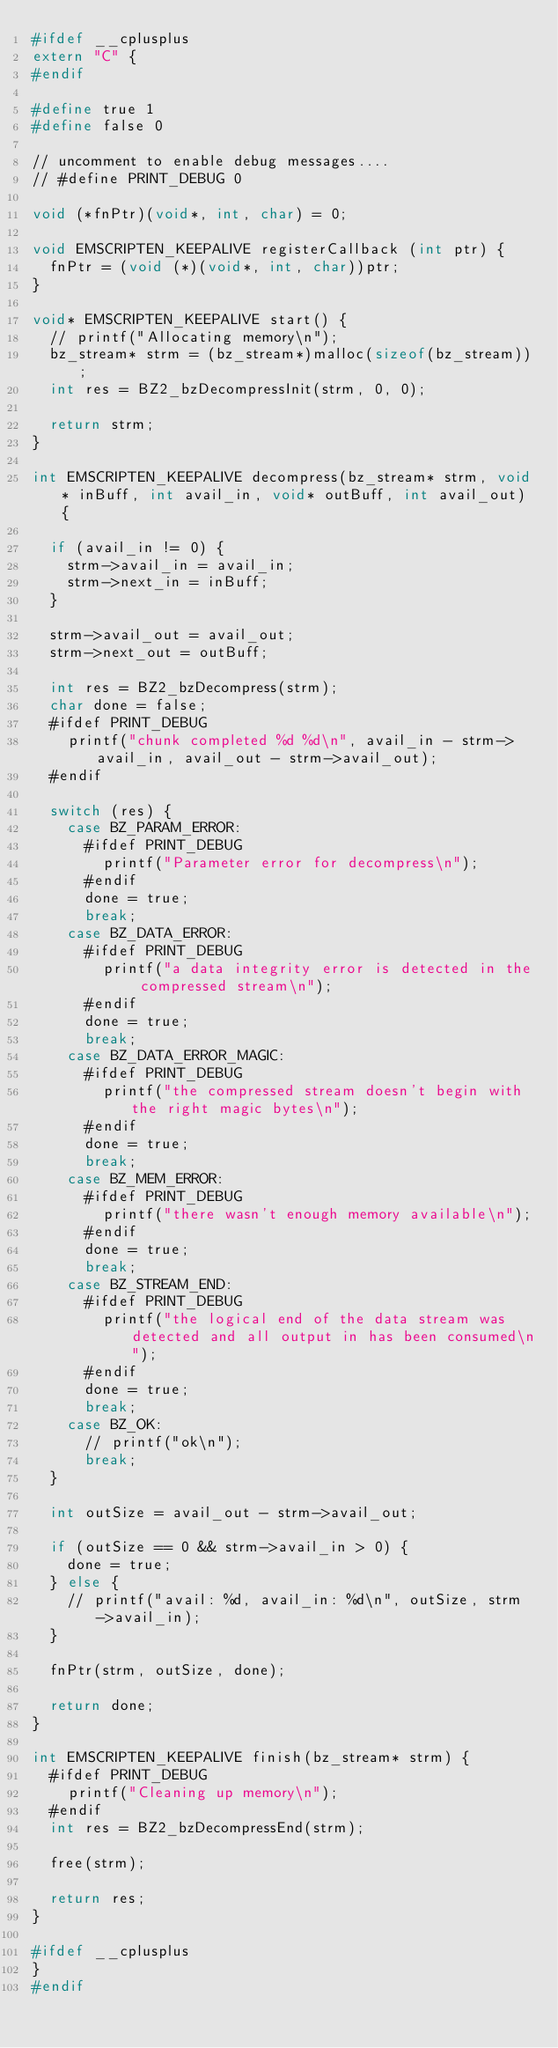<code> <loc_0><loc_0><loc_500><loc_500><_C_>#ifdef __cplusplus
extern "C" {
#endif

#define true 1
#define false 0

// uncomment to enable debug messages....
// #define PRINT_DEBUG 0

void (*fnPtr)(void*, int, char) = 0;

void EMSCRIPTEN_KEEPALIVE registerCallback (int ptr) {
  fnPtr = (void (*)(void*, int, char))ptr;
}

void* EMSCRIPTEN_KEEPALIVE start() {
  // printf("Allocating memory\n");
  bz_stream* strm = (bz_stream*)malloc(sizeof(bz_stream));
  int res = BZ2_bzDecompressInit(strm, 0, 0);

  return strm;
}

int EMSCRIPTEN_KEEPALIVE decompress(bz_stream* strm, void* inBuff, int avail_in, void* outBuff, int avail_out) {
  
  if (avail_in != 0) {
    strm->avail_in = avail_in;
    strm->next_in = inBuff;
  }

  strm->avail_out = avail_out;
  strm->next_out = outBuff;

  int res = BZ2_bzDecompress(strm);
  char done = false;
  #ifdef PRINT_DEBUG
    printf("chunk completed %d %d\n", avail_in - strm->avail_in, avail_out - strm->avail_out);
  #endif

  switch (res) {
    case BZ_PARAM_ERROR:
      #ifdef PRINT_DEBUG
        printf("Parameter error for decompress\n");
      #endif
      done = true;
      break;
    case BZ_DATA_ERROR:
      #ifdef PRINT_DEBUG
        printf("a data integrity error is detected in the compressed stream\n");
      #endif
      done = true;
      break;
    case BZ_DATA_ERROR_MAGIC:
      #ifdef PRINT_DEBUG
        printf("the compressed stream doesn't begin with the right magic bytes\n");
      #endif
      done = true;
      break;
    case BZ_MEM_ERROR:
      #ifdef PRINT_DEBUG
        printf("there wasn't enough memory available\n");
      #endif
      done = true;
      break;
    case BZ_STREAM_END:
      #ifdef PRINT_DEBUG
        printf("the logical end of the data stream was detected and all output in has been consumed\n");
      #endif
      done = true;
      break;
    case BZ_OK:
      // printf("ok\n");
      break;
  }

  int outSize = avail_out - strm->avail_out;

  if (outSize == 0 && strm->avail_in > 0) {
    done = true;
  } else {
    // printf("avail: %d, avail_in: %d\n", outSize, strm->avail_in);
  }

  fnPtr(strm, outSize, done);

  return done;
}

int EMSCRIPTEN_KEEPALIVE finish(bz_stream* strm) {
  #ifdef PRINT_DEBUG
    printf("Cleaning up memory\n");
  #endif
  int res = BZ2_bzDecompressEnd(strm);

  free(strm);

  return res;
}

#ifdef __cplusplus
}
#endif
</code> 